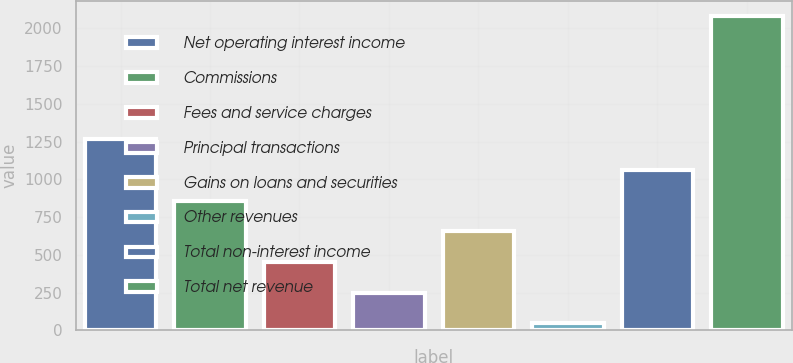Convert chart to OTSL. <chart><loc_0><loc_0><loc_500><loc_500><bar_chart><fcel>Net operating interest income<fcel>Commissions<fcel>Fees and service charges<fcel>Principal transactions<fcel>Gains on loans and securities<fcel>Other revenues<fcel>Total non-interest income<fcel>Total net revenue<nl><fcel>1265.26<fcel>858.94<fcel>452.62<fcel>249.46<fcel>655.78<fcel>46.3<fcel>1062.1<fcel>2077.9<nl></chart> 